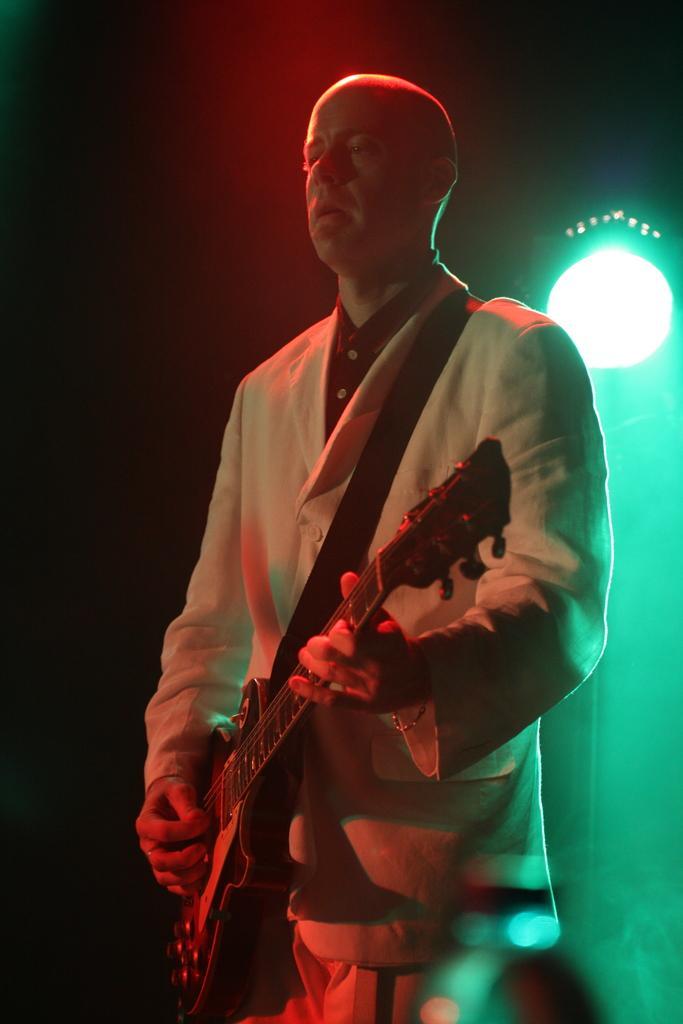Please provide a concise description of this image. As we can see in the image there is a man holding guitar. 